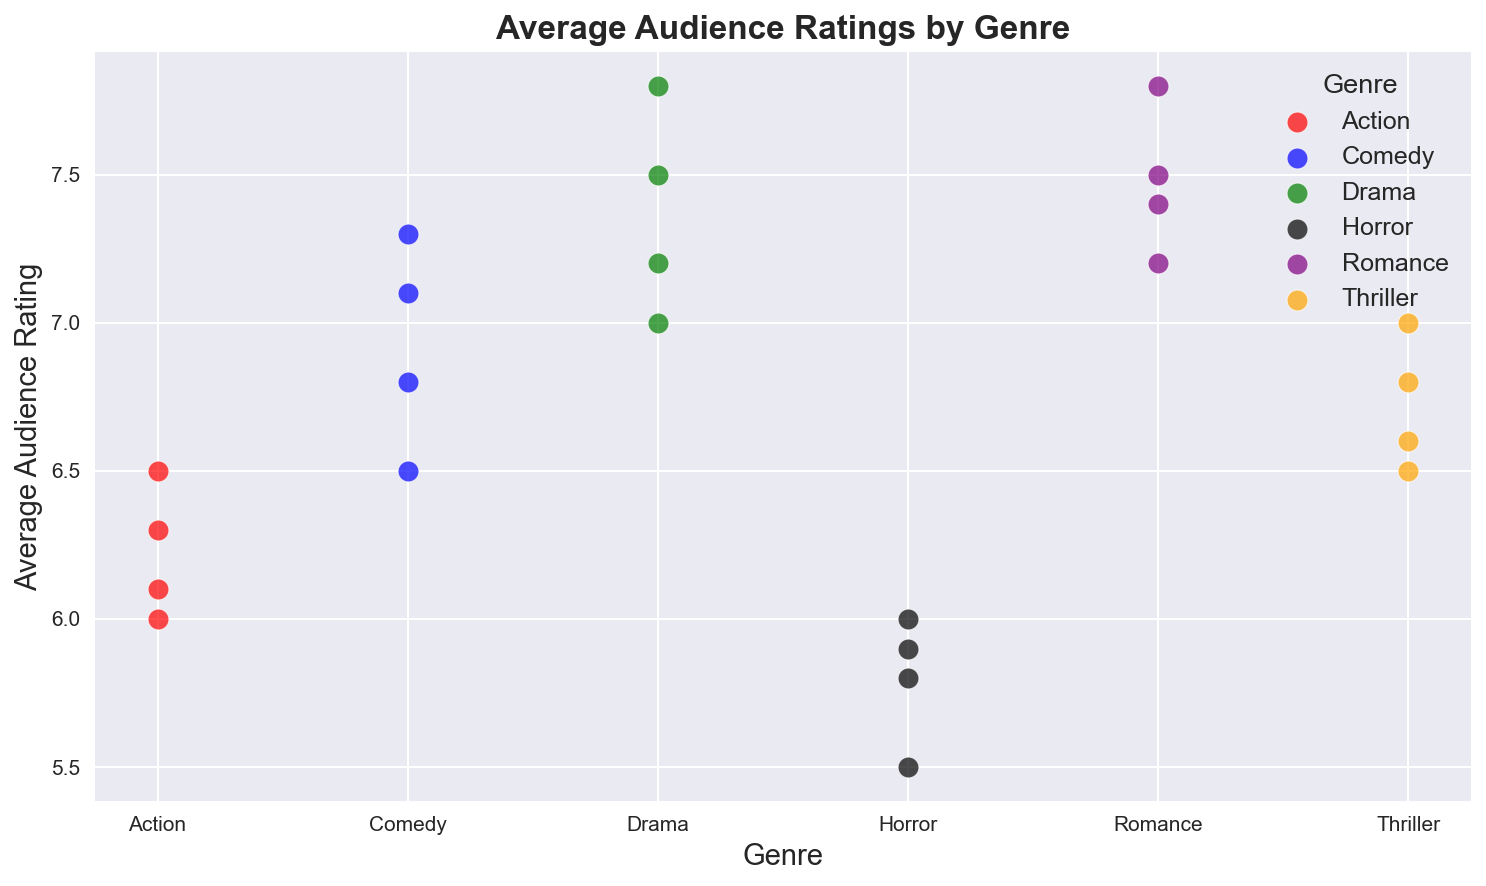Which genre has the highest average audience rating? To determine which genre has the highest average audience rating, we compare the positions of each genre's points on the y-axis. The highest points on the y-axis represent the highest average audience ratings. Romance tends to have the highest points among all the genres displayed.
Answer: Romance Which genre has the most varied range of audience ratings? To identify the genre with the most varied range of audience ratings, we compare the spread of data points on the y-axis for each genre. A wider spread indicates more variation. Both Drama and Comedy show a noticeable spread of points, but Drama seems to have a slightly larger range.
Answer: Drama How does the average audience rating for Action compare to Horror? By visually comparing the average positions of the data points for Action and Horror on the y-axis, we can observe that the average ratings for Action are slightly higher than those for Horror. Horror ratings are closer to 5.5 to 6.0, whereas Action is around 6.0 to 6.5.
Answer: Action is higher What is the average audience rating for the Comedy genre? To find the average audience rating for Comedy, we sum the ratings (6.8, 7.1, 6.5, 7.3) and then divide by the number of data points (4). The calculation is (6.8 + 7.1 + 6.5 + 7.3) / 4.
Answer: 6.93 Which genre has the lowest average audience rating, and what is this rating? We identify the genre with the lowest data points on the y-axis. Horror has the lowest data points. To find the exact rating, we observe the specific values (5.5, 5.8, 5.9, 6.0) and take the average which turns out to be lower compared to other genres.
Answer: Horror with a rating of 5.8 Comparing Drama and Thriller, which genre exhibits a higher audience rating range? We compare the vertical spread of the ratings for Drama and Thriller. Drama's ratings range approximately from 7.0 to 7.8, while Thriller's ratings range from 6.5 to 7.0. Drama has a higher rating range.
Answer: Drama Which genres have average audience ratings clustered between 6.5 and 7.5? By scanning the figure for points that lie between 6.5 and 7.5 on the y-axis, we find that Comedy, Drama, Thriller, and some points in Romance fall into this range. These genres have a notable concentration of points in this interval.
Answer: Comedy, Drama, Thriller, Romance What is the combined average audience rating of Action and Horror? To calculate this, we sum the ratings of Action (6.0, 6.5, 6.1, 6.3) and Horror (5.5, 5.8, 5.9, 6.0), then divide by the total number of data points (8). The sum is (6.0 + 6.5 + 6.1 + 6.3 + 5.5 + 5.8 + 5.9 + 6.0) which comes to 47.1, and dividing by 8 gives us 5.89.
Answer: 5.89 Does any genre show no overlap with others in terms of audience ratings? Checking the scatter plot for each genre's rating range and comparing with others, we observe that most genres overlap, but Horror has a lower rating range not shared with others (5.5 to 6.0).
Answer: Horror How does the rating variability of Romance compare to Comedy? We compare the vertical distribution (spread) of the rating points of Romance and Comedy. Romance's ratings are relatively close together (7.2, 7.4, 7.5, 7.8) while Comedy's ratings (6.5 to 7.3) show more variability.
Answer: Comedy is more varied 